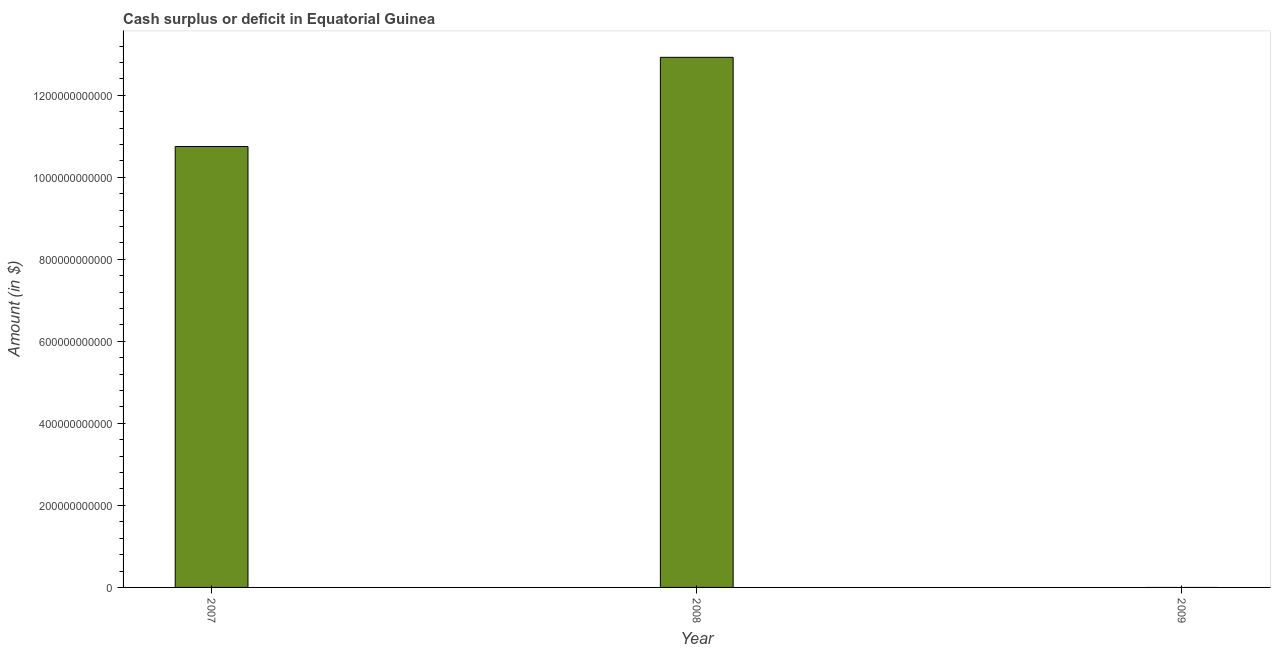Does the graph contain any zero values?
Make the answer very short. Yes. What is the title of the graph?
Keep it short and to the point. Cash surplus or deficit in Equatorial Guinea. What is the label or title of the Y-axis?
Offer a very short reply. Amount (in $). What is the cash surplus or deficit in 2008?
Offer a very short reply. 1.29e+12. Across all years, what is the maximum cash surplus or deficit?
Make the answer very short. 1.29e+12. What is the sum of the cash surplus or deficit?
Offer a terse response. 2.37e+12. What is the difference between the cash surplus or deficit in 2007 and 2008?
Make the answer very short. -2.17e+11. What is the average cash surplus or deficit per year?
Give a very brief answer. 7.89e+11. What is the median cash surplus or deficit?
Offer a terse response. 1.08e+12. In how many years, is the cash surplus or deficit greater than 320000000000 $?
Your answer should be compact. 2. What is the ratio of the cash surplus or deficit in 2007 to that in 2008?
Provide a short and direct response. 0.83. Is the difference between the cash surplus or deficit in 2007 and 2008 greater than the difference between any two years?
Your response must be concise. No. Is the sum of the cash surplus or deficit in 2007 and 2008 greater than the maximum cash surplus or deficit across all years?
Your response must be concise. Yes. What is the difference between the highest and the lowest cash surplus or deficit?
Provide a succinct answer. 1.29e+12. In how many years, is the cash surplus or deficit greater than the average cash surplus or deficit taken over all years?
Offer a terse response. 2. How many bars are there?
Your answer should be compact. 2. Are all the bars in the graph horizontal?
Keep it short and to the point. No. What is the difference between two consecutive major ticks on the Y-axis?
Your response must be concise. 2.00e+11. What is the Amount (in $) of 2007?
Offer a terse response. 1.08e+12. What is the Amount (in $) of 2008?
Your response must be concise. 1.29e+12. What is the difference between the Amount (in $) in 2007 and 2008?
Provide a succinct answer. -2.17e+11. What is the ratio of the Amount (in $) in 2007 to that in 2008?
Provide a succinct answer. 0.83. 